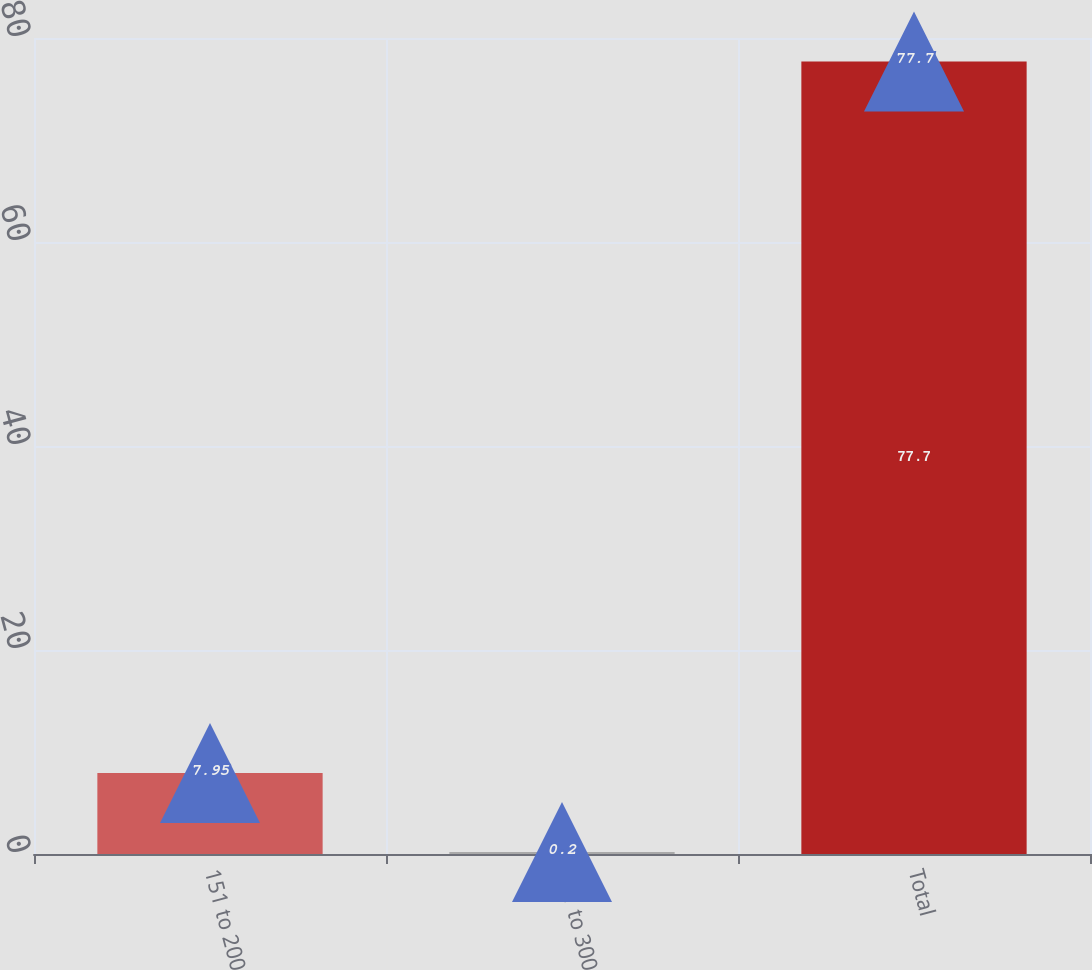Convert chart to OTSL. <chart><loc_0><loc_0><loc_500><loc_500><bar_chart><fcel>151 to 200<fcel>251 to 300<fcel>Total<nl><fcel>7.95<fcel>0.2<fcel>77.7<nl></chart> 